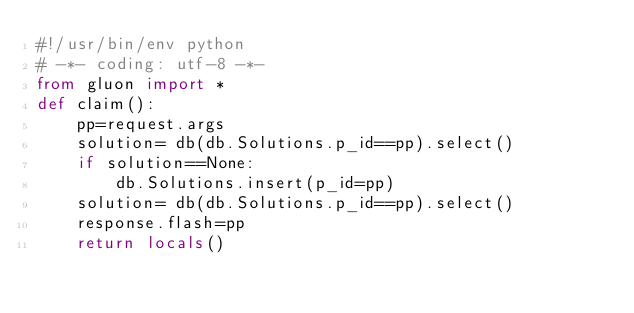Convert code to text. <code><loc_0><loc_0><loc_500><loc_500><_Python_>#!/usr/bin/env python
# -*- coding: utf-8 -*-
from gluon import *
def claim():
    pp=request.args
    solution= db(db.Solutions.p_id==pp).select()
    if solution==None:
        db.Solutions.insert(p_id=pp)
    solution= db(db.Solutions.p_id==pp).select()
    response.flash=pp
    return locals()
</code> 